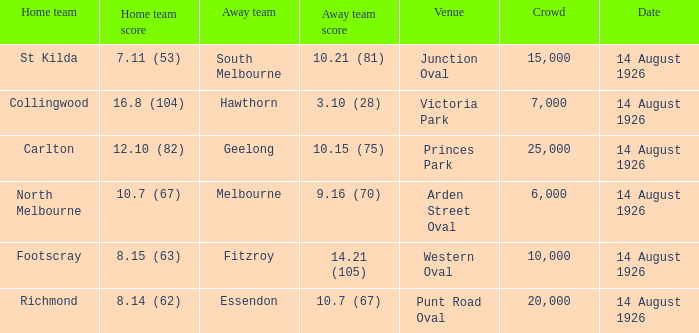What was the crowd size at Victoria Park? 7000.0. 